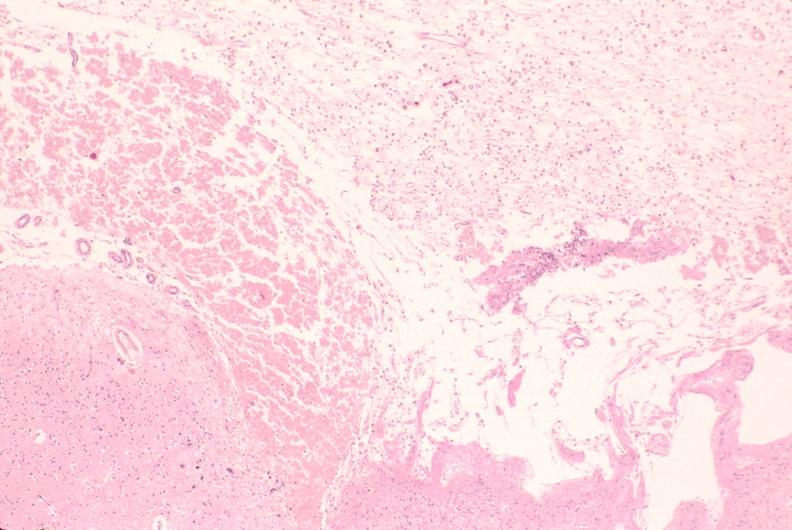what is present?
Answer the question using a single word or phrase. Nervous 